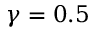<formula> <loc_0><loc_0><loc_500><loc_500>\gamma = 0 . 5</formula> 